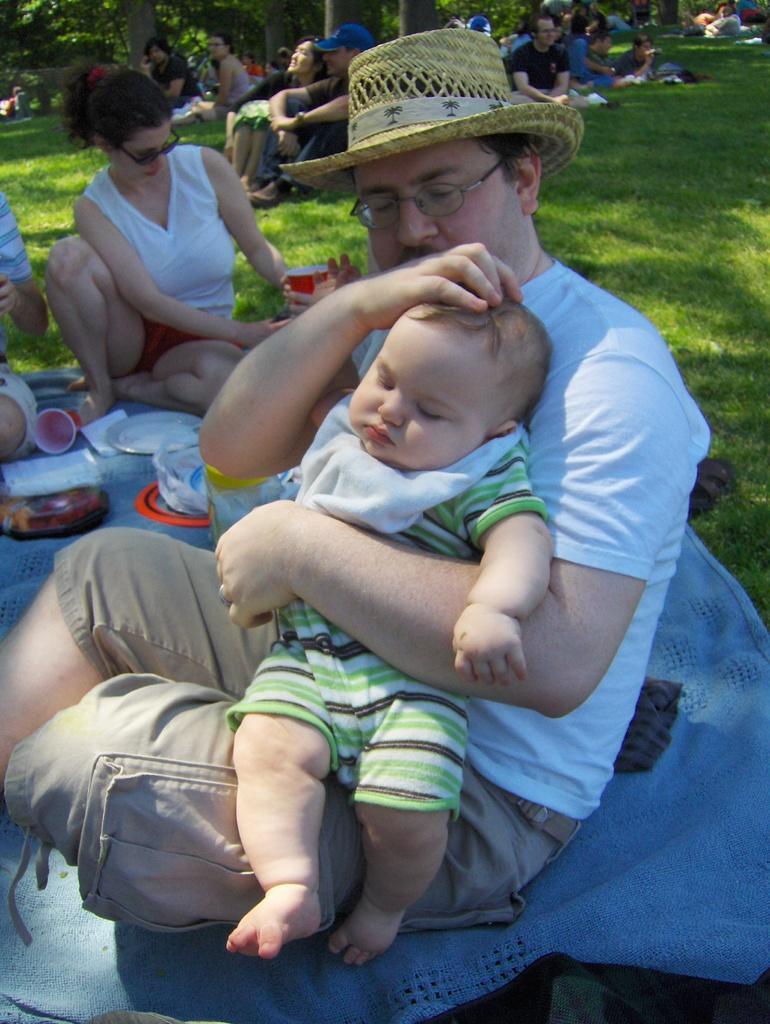Please provide a concise description of this image. In the foreground of the picture I can see a man sitting on the blue color cloth and he is holding a baby. I can see a few persons sitting on the green grass. In the background, I can see the trees. 